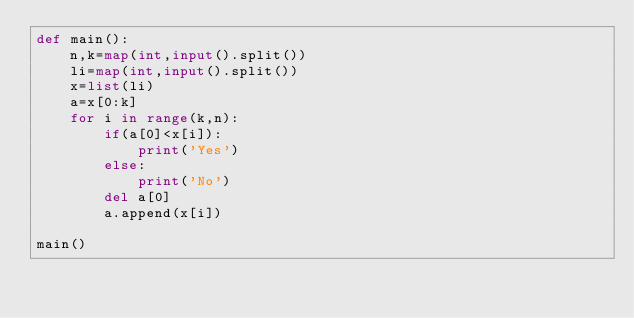<code> <loc_0><loc_0><loc_500><loc_500><_Python_>def main():
    n,k=map(int,input().split())
    li=map(int,input().split())
    x=list(li)
    a=x[0:k]
    for i in range(k,n):
        if(a[0]<x[i]):
            print('Yes')
        else:
            print('No')
        del a[0]
        a.append(x[i])
    
main()
</code> 